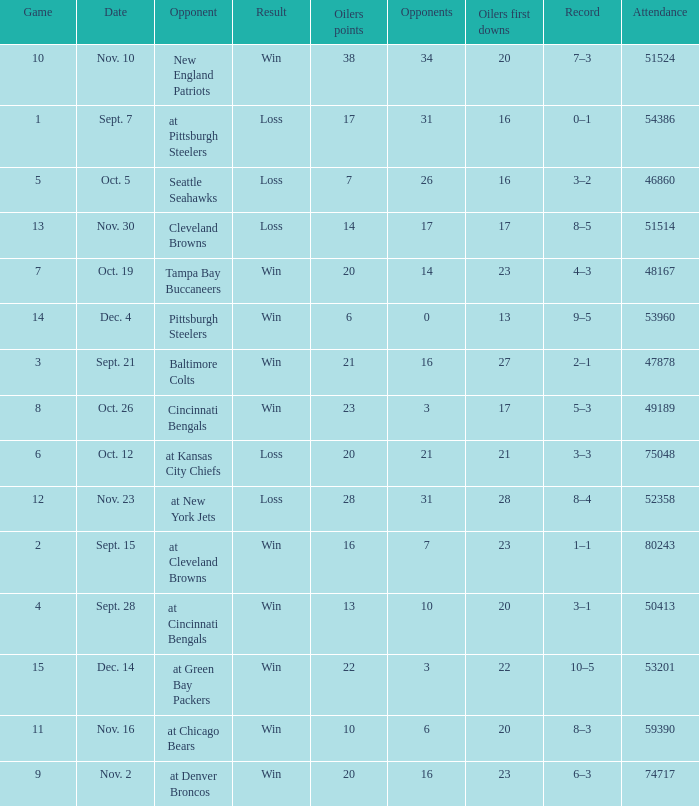What was the total opponents points for the game were the Oilers scored 21? 16.0. 